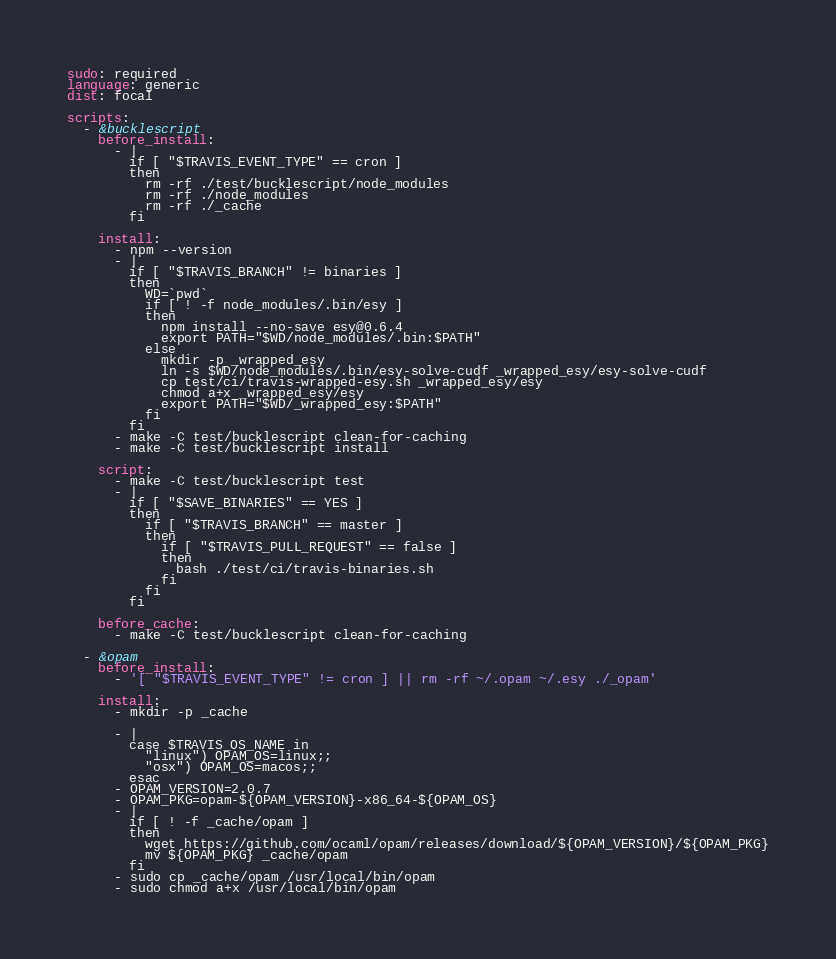Convert code to text. <code><loc_0><loc_0><loc_500><loc_500><_YAML_>sudo: required
language: generic
dist: focal

scripts:
  - &bucklescript
    before_install:
      - |
        if [ "$TRAVIS_EVENT_TYPE" == cron ]
        then
          rm -rf ./test/bucklescript/node_modules
          rm -rf ./node_modules
          rm -rf ./_cache
        fi

    install:
      - npm --version
      - |
        if [ "$TRAVIS_BRANCH" != binaries ]
        then
          WD=`pwd`
          if [ ! -f node_modules/.bin/esy ]
          then
            npm install --no-save esy@0.6.4
            export PATH="$WD/node_modules/.bin:$PATH"
          else
            mkdir -p _wrapped_esy
            ln -s $WD/node_modules/.bin/esy-solve-cudf _wrapped_esy/esy-solve-cudf
            cp test/ci/travis-wrapped-esy.sh _wrapped_esy/esy
            chmod a+x _wrapped_esy/esy
            export PATH="$WD/_wrapped_esy:$PATH"
          fi
        fi
      - make -C test/bucklescript clean-for-caching
      - make -C test/bucklescript install

    script:
      - make -C test/bucklescript test
      - |
        if [ "$SAVE_BINARIES" == YES ]
        then
          if [ "$TRAVIS_BRANCH" == master ]
          then
            if [ "$TRAVIS_PULL_REQUEST" == false ]
            then
              bash ./test/ci/travis-binaries.sh
            fi
          fi
        fi

    before_cache:
      - make -C test/bucklescript clean-for-caching

  - &opam
    before_install:
      - '[ "$TRAVIS_EVENT_TYPE" != cron ] || rm -rf ~/.opam ~/.esy ./_opam'

    install:
      - mkdir -p _cache

      - |
        case $TRAVIS_OS_NAME in
          "linux") OPAM_OS=linux;;
          "osx") OPAM_OS=macos;;
        esac
      - OPAM_VERSION=2.0.7
      - OPAM_PKG=opam-${OPAM_VERSION}-x86_64-${OPAM_OS}
      - |
        if [ ! -f _cache/opam ]
        then
          wget https://github.com/ocaml/opam/releases/download/${OPAM_VERSION}/${OPAM_PKG}
          mv ${OPAM_PKG} _cache/opam
        fi
      - sudo cp _cache/opam /usr/local/bin/opam
      - sudo chmod a+x /usr/local/bin/opam
</code> 